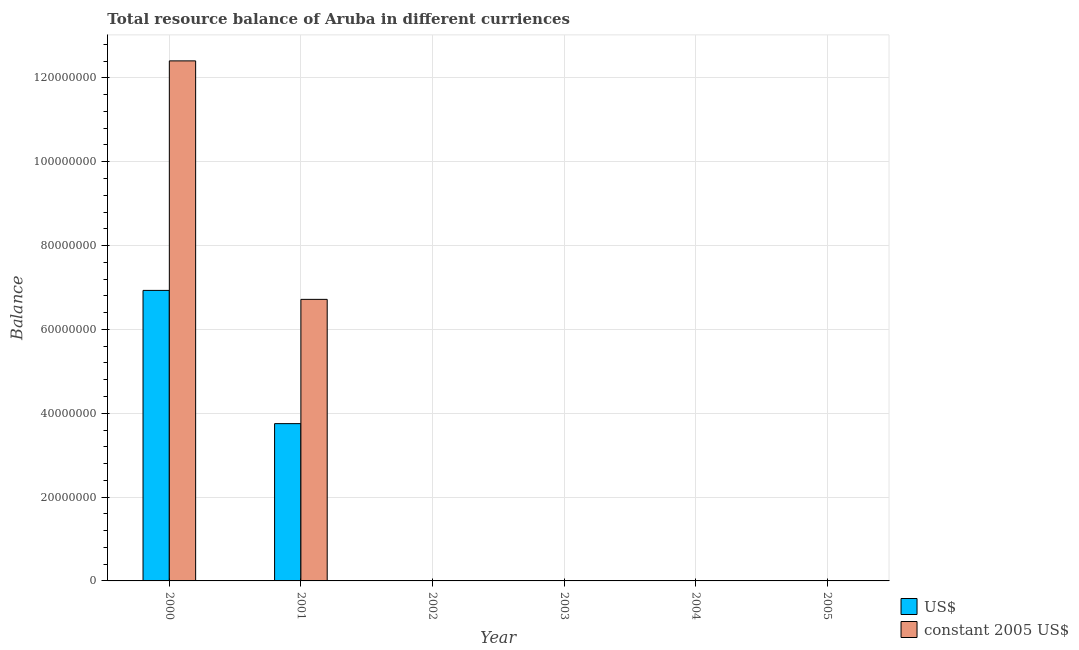Are the number of bars on each tick of the X-axis equal?
Offer a very short reply. No. How many bars are there on the 3rd tick from the left?
Give a very brief answer. 0. How many bars are there on the 6th tick from the right?
Offer a very short reply. 2. In how many cases, is the number of bars for a given year not equal to the number of legend labels?
Offer a very short reply. 4. What is the resource balance in us$ in 2002?
Provide a succinct answer. 0. Across all years, what is the maximum resource balance in constant us$?
Offer a terse response. 1.24e+08. In which year was the resource balance in constant us$ maximum?
Your answer should be compact. 2000. What is the total resource balance in constant us$ in the graph?
Your answer should be compact. 1.91e+08. What is the difference between the resource balance in us$ in 2000 and that in 2001?
Your answer should be compact. 3.18e+07. What is the difference between the resource balance in us$ in 2001 and the resource balance in constant us$ in 2000?
Give a very brief answer. -3.18e+07. What is the average resource balance in constant us$ per year?
Provide a succinct answer. 3.19e+07. In how many years, is the resource balance in us$ greater than 108000000 units?
Make the answer very short. 0. What is the ratio of the resource balance in us$ in 2000 to that in 2001?
Provide a succinct answer. 1.85. What is the difference between the highest and the lowest resource balance in constant us$?
Your answer should be compact. 1.24e+08. In how many years, is the resource balance in us$ greater than the average resource balance in us$ taken over all years?
Ensure brevity in your answer.  2. How many bars are there?
Your answer should be compact. 4. What is the difference between two consecutive major ticks on the Y-axis?
Make the answer very short. 2.00e+07. Does the graph contain any zero values?
Your answer should be very brief. Yes. Where does the legend appear in the graph?
Offer a terse response. Bottom right. How many legend labels are there?
Your answer should be very brief. 2. What is the title of the graph?
Make the answer very short. Total resource balance of Aruba in different curriences. Does "IMF concessional" appear as one of the legend labels in the graph?
Give a very brief answer. No. What is the label or title of the Y-axis?
Provide a succinct answer. Balance. What is the Balance in US$ in 2000?
Offer a terse response. 6.93e+07. What is the Balance in constant 2005 US$ in 2000?
Offer a terse response. 1.24e+08. What is the Balance in US$ in 2001?
Offer a terse response. 3.75e+07. What is the Balance of constant 2005 US$ in 2001?
Ensure brevity in your answer.  6.72e+07. What is the Balance of US$ in 2003?
Provide a short and direct response. 0. What is the Balance of constant 2005 US$ in 2003?
Your answer should be compact. 0. What is the Balance of constant 2005 US$ in 2005?
Provide a succinct answer. 0. Across all years, what is the maximum Balance of US$?
Make the answer very short. 6.93e+07. Across all years, what is the maximum Balance of constant 2005 US$?
Offer a very short reply. 1.24e+08. Across all years, what is the minimum Balance in constant 2005 US$?
Give a very brief answer. 0. What is the total Balance in US$ in the graph?
Provide a succinct answer. 1.07e+08. What is the total Balance of constant 2005 US$ in the graph?
Ensure brevity in your answer.  1.91e+08. What is the difference between the Balance of US$ in 2000 and that in 2001?
Ensure brevity in your answer.  3.18e+07. What is the difference between the Balance of constant 2005 US$ in 2000 and that in 2001?
Provide a succinct answer. 5.69e+07. What is the difference between the Balance in US$ in 2000 and the Balance in constant 2005 US$ in 2001?
Offer a terse response. 2.14e+06. What is the average Balance in US$ per year?
Offer a terse response. 1.78e+07. What is the average Balance in constant 2005 US$ per year?
Offer a terse response. 3.19e+07. In the year 2000, what is the difference between the Balance in US$ and Balance in constant 2005 US$?
Offer a terse response. -5.47e+07. In the year 2001, what is the difference between the Balance in US$ and Balance in constant 2005 US$?
Provide a short and direct response. -2.96e+07. What is the ratio of the Balance in US$ in 2000 to that in 2001?
Offer a very short reply. 1.85. What is the ratio of the Balance of constant 2005 US$ in 2000 to that in 2001?
Offer a terse response. 1.85. What is the difference between the highest and the lowest Balance of US$?
Offer a terse response. 6.93e+07. What is the difference between the highest and the lowest Balance in constant 2005 US$?
Give a very brief answer. 1.24e+08. 